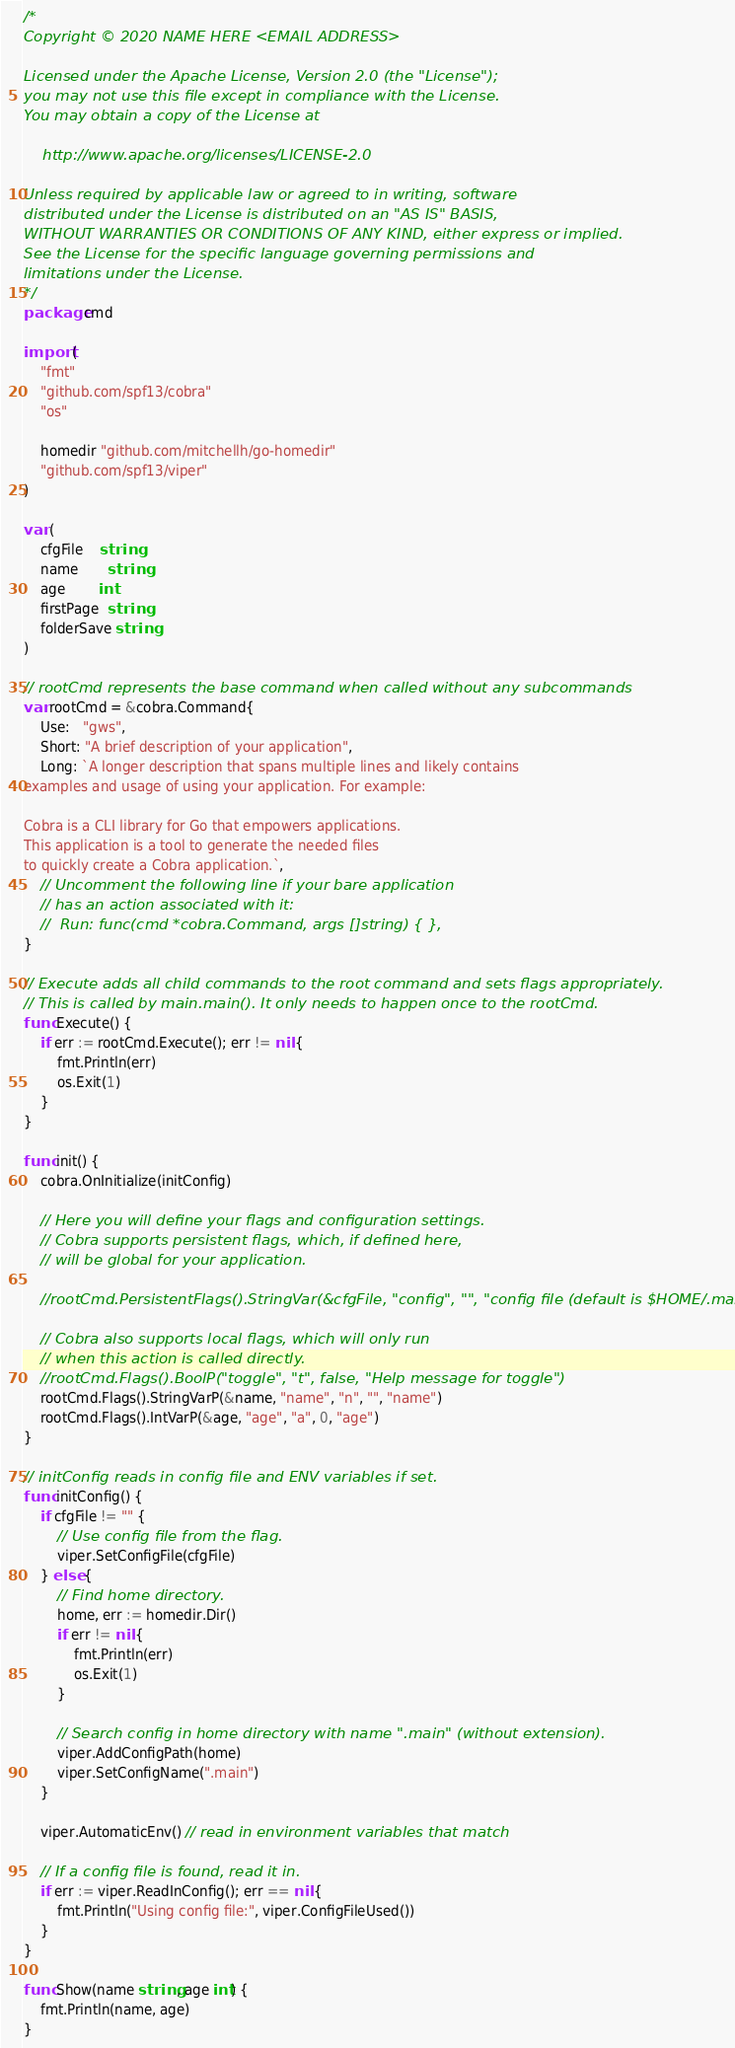<code> <loc_0><loc_0><loc_500><loc_500><_Go_>/*
Copyright © 2020 NAME HERE <EMAIL ADDRESS>

Licensed under the Apache License, Version 2.0 (the "License");
you may not use this file except in compliance with the License.
You may obtain a copy of the License at

    http://www.apache.org/licenses/LICENSE-2.0

Unless required by applicable law or agreed to in writing, software
distributed under the License is distributed on an "AS IS" BASIS,
WITHOUT WARRANTIES OR CONDITIONS OF ANY KIND, either express or implied.
See the License for the specific language governing permissions and
limitations under the License.
*/
package cmd

import (
	"fmt"
	"github.com/spf13/cobra"
	"os"

	homedir "github.com/mitchellh/go-homedir"
	"github.com/spf13/viper"
)

var (
	cfgFile    string
	name       string
	age        int
	firstPage  string
	folderSave string
)

// rootCmd represents the base command when called without any subcommands
var rootCmd = &cobra.Command{
	Use:   "gws",
	Short: "A brief description of your application",
	Long: `A longer description that spans multiple lines and likely contains
examples and usage of using your application. For example:

Cobra is a CLI library for Go that empowers applications.
This application is a tool to generate the needed files
to quickly create a Cobra application.`,
	// Uncomment the following line if your bare application
	// has an action associated with it:
	//	Run: func(cmd *cobra.Command, args []string) { },
}

// Execute adds all child commands to the root command and sets flags appropriately.
// This is called by main.main(). It only needs to happen once to the rootCmd.
func Execute() {
	if err := rootCmd.Execute(); err != nil {
		fmt.Println(err)
		os.Exit(1)
	}
}

func init() {
	cobra.OnInitialize(initConfig)

	// Here you will define your flags and configuration settings.
	// Cobra supports persistent flags, which, if defined here,
	// will be global for your application.

	//rootCmd.PersistentFlags().StringVar(&cfgFile, "config", "", "config file (default is $HOME/.main.yaml)")

	// Cobra also supports local flags, which will only run
	// when this action is called directly.
	//rootCmd.Flags().BoolP("toggle", "t", false, "Help message for toggle")
	rootCmd.Flags().StringVarP(&name, "name", "n", "", "name")
	rootCmd.Flags().IntVarP(&age, "age", "a", 0, "age")
}

// initConfig reads in config file and ENV variables if set.
func initConfig() {
	if cfgFile != "" {
		// Use config file from the flag.
		viper.SetConfigFile(cfgFile)
	} else {
		// Find home directory.
		home, err := homedir.Dir()
		if err != nil {
			fmt.Println(err)
			os.Exit(1)
		}

		// Search config in home directory with name ".main" (without extension).
		viper.AddConfigPath(home)
		viper.SetConfigName(".main")
	}

	viper.AutomaticEnv() // read in environment variables that match

	// If a config file is found, read it in.
	if err := viper.ReadInConfig(); err == nil {
		fmt.Println("Using config file:", viper.ConfigFileUsed())
	}
}

func Show(name string, age int) {
	fmt.Println(name, age)
}
</code> 